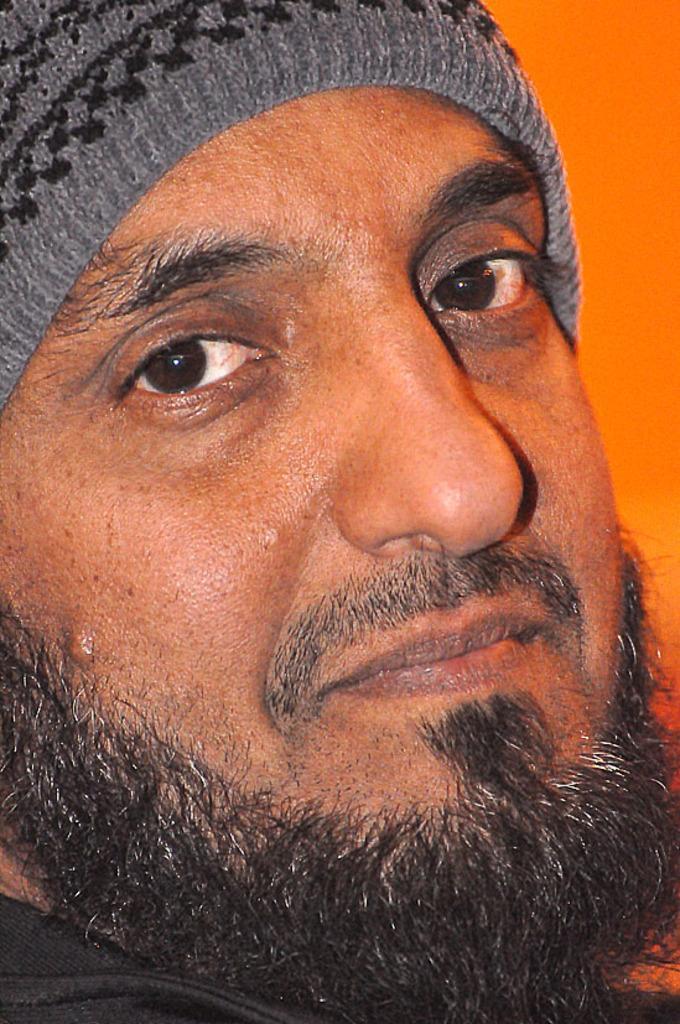In one or two sentences, can you explain what this image depicts? In this picture, the man in black jacket and grey cap is looking at the camera and he is smiling. In the background, it is orange in color. 